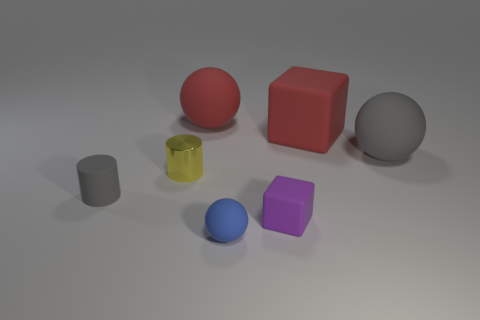Can you describe the shapes and colors of the objects in the picture? Certainly! In the image, there are six objects with distinct shapes and colors. From the left, we have a grey cylinder, a small yellow cylinder, a blue sphere, a purple cube, a red sphere, and a grey cube. Each object is rendered with a smooth surface and has a soft shadow cast on the ground, showing a light source above the arrangement. 